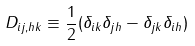Convert formula to latex. <formula><loc_0><loc_0><loc_500><loc_500>D _ { i j , h k } \equiv \frac { 1 } { 2 } ( \delta _ { i k } \delta _ { j h } - \delta _ { j k } \delta _ { i h } )</formula> 